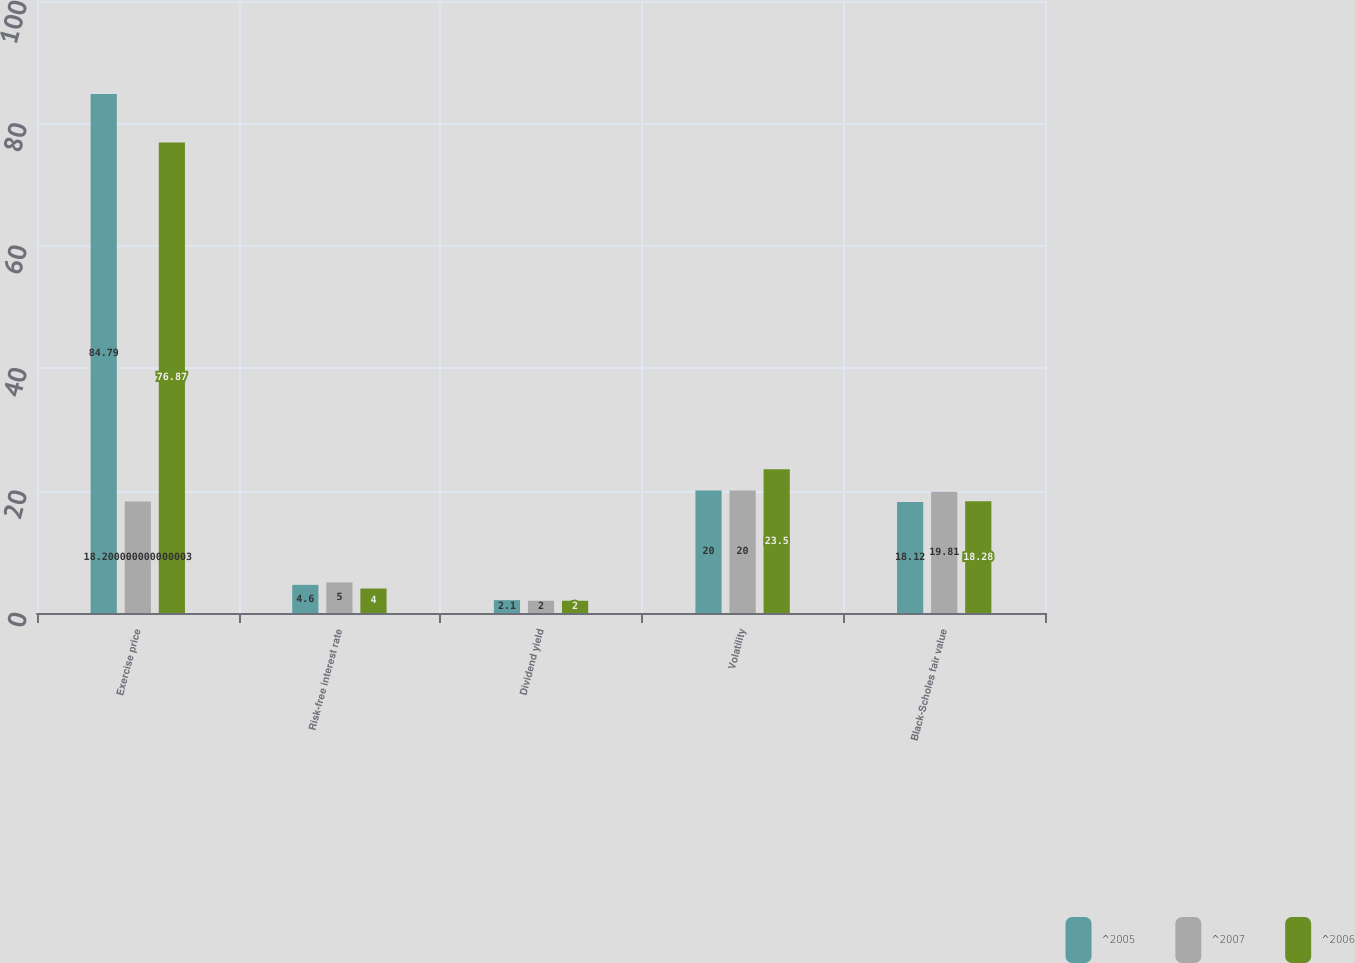Convert chart. <chart><loc_0><loc_0><loc_500><loc_500><stacked_bar_chart><ecel><fcel>Exercise price<fcel>Risk-free interest rate<fcel>Dividend yield<fcel>Volatility<fcel>Black-Scholes fair value<nl><fcel>^2005<fcel>84.79<fcel>4.6<fcel>2.1<fcel>20<fcel>18.12<nl><fcel>^2007<fcel>18.2<fcel>5<fcel>2<fcel>20<fcel>19.81<nl><fcel>^2006<fcel>76.87<fcel>4<fcel>2<fcel>23.5<fcel>18.28<nl></chart> 